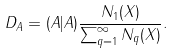<formula> <loc_0><loc_0><loc_500><loc_500>D _ { A } = ( A | A ) \frac { N _ { 1 } ( X ) } { \sum _ { q = 1 } ^ { \infty } N _ { q } ( X ) } .</formula> 